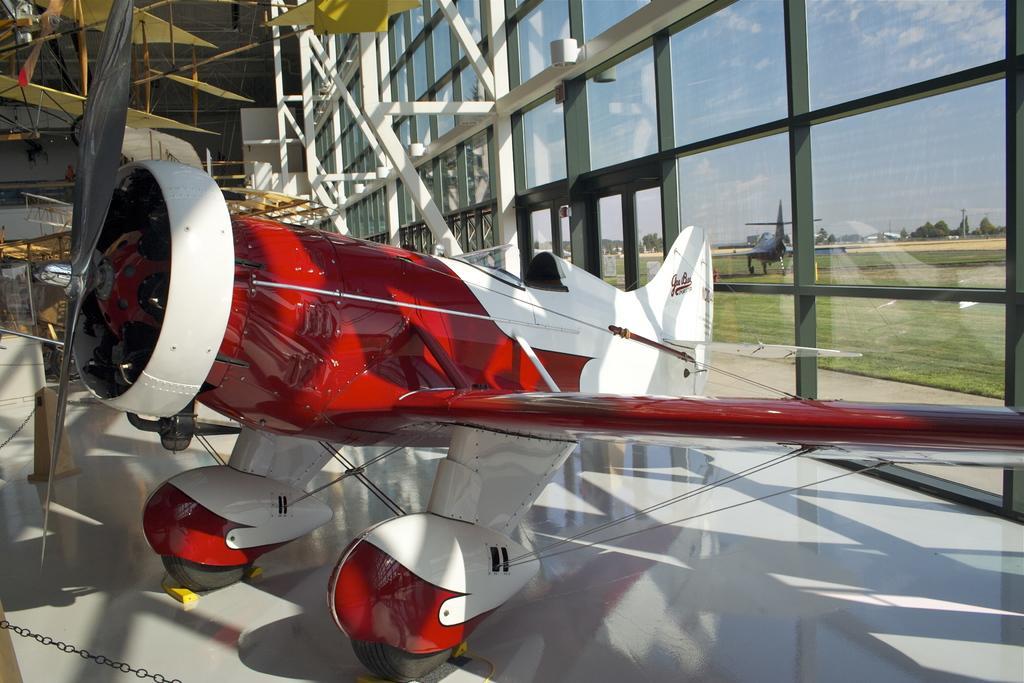Can you describe this image briefly? In the image we can see the flying jet, red and white in color. Here we can see glass wall and out of the glass wall we can see the grass, trees, pole, the sky and another flying jet. 